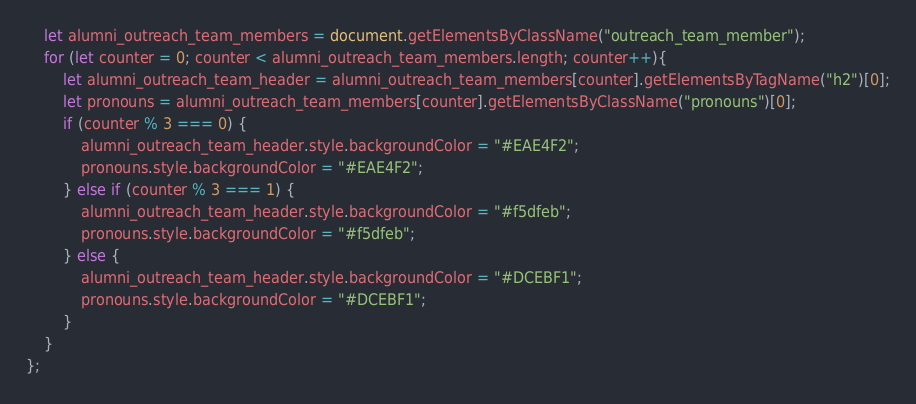<code> <loc_0><loc_0><loc_500><loc_500><_JavaScript_>    let alumni_outreach_team_members = document.getElementsByClassName("outreach_team_member");
    for (let counter = 0; counter < alumni_outreach_team_members.length; counter++){
        let alumni_outreach_team_header = alumni_outreach_team_members[counter].getElementsByTagName("h2")[0];
        let pronouns = alumni_outreach_team_members[counter].getElementsByClassName("pronouns")[0];
        if (counter % 3 === 0) {
            alumni_outreach_team_header.style.backgroundColor = "#EAE4F2";
            pronouns.style.backgroundColor = "#EAE4F2";
        } else if (counter % 3 === 1) {
            alumni_outreach_team_header.style.backgroundColor = "#f5dfeb";
            pronouns.style.backgroundColor = "#f5dfeb";
        } else {
            alumni_outreach_team_header.style.backgroundColor = "#DCEBF1";
            pronouns.style.backgroundColor = "#DCEBF1";
        }
    }
};</code> 